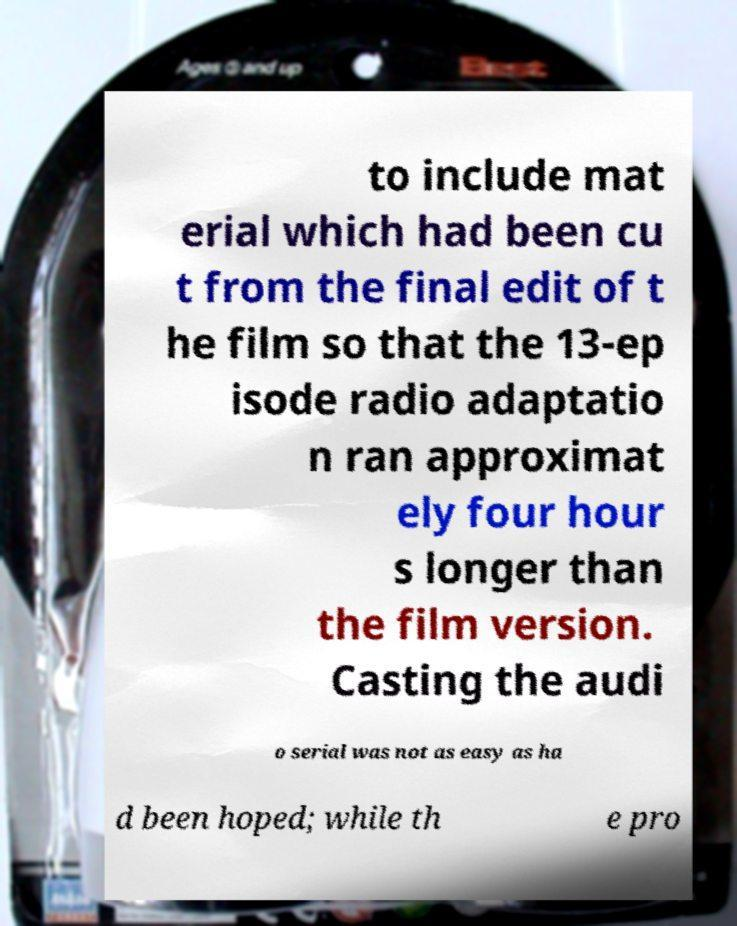Could you extract and type out the text from this image? to include mat erial which had been cu t from the final edit of t he film so that the 13-ep isode radio adaptatio n ran approximat ely four hour s longer than the film version. Casting the audi o serial was not as easy as ha d been hoped; while th e pro 